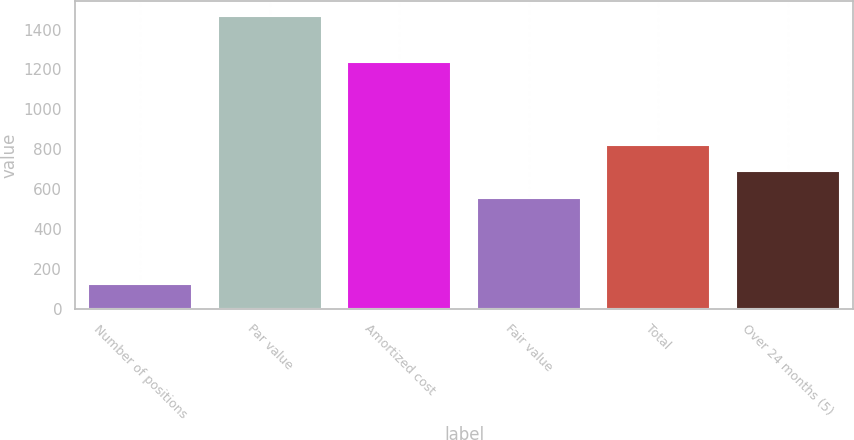<chart> <loc_0><loc_0><loc_500><loc_500><bar_chart><fcel>Number of positions<fcel>Par value<fcel>Amortized cost<fcel>Fair value<fcel>Total<fcel>Over 24 months (5)<nl><fcel>128<fcel>1467<fcel>1239<fcel>556<fcel>823.8<fcel>689.9<nl></chart> 